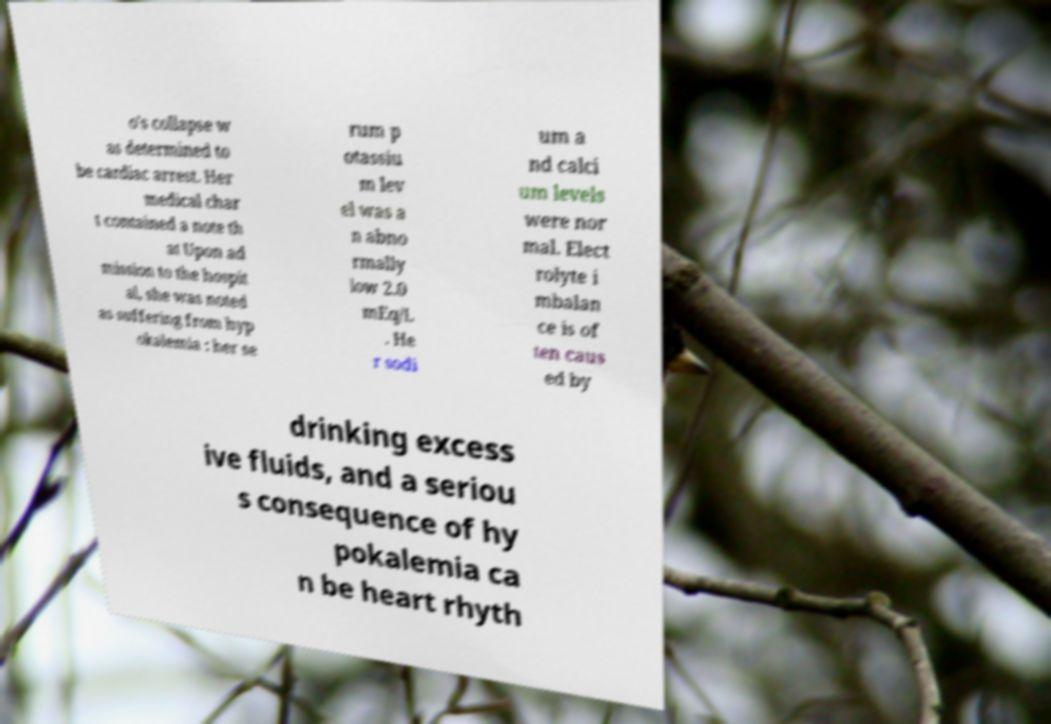Please read and relay the text visible in this image. What does it say? o's collapse w as determined to be cardiac arrest. Her medical char t contained a note th at Upon ad mission to the hospit al, she was noted as suffering from hyp okalemia : her se rum p otassiu m lev el was a n abno rmally low 2.0 mEq/L . He r sodi um a nd calci um levels were nor mal. Elect rolyte i mbalan ce is of ten caus ed by drinking excess ive fluids, and a seriou s consequence of hy pokalemia ca n be heart rhyth 